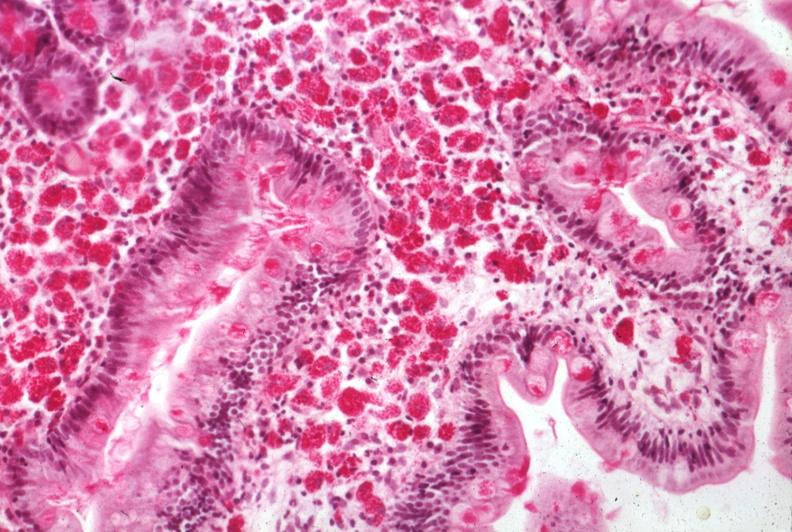what is present?
Answer the question using a single word or phrase. Intestine 